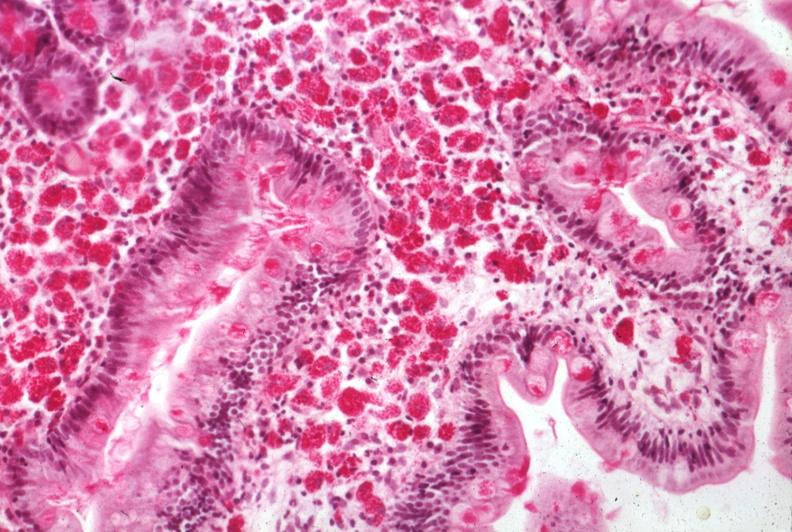what is present?
Answer the question using a single word or phrase. Intestine 